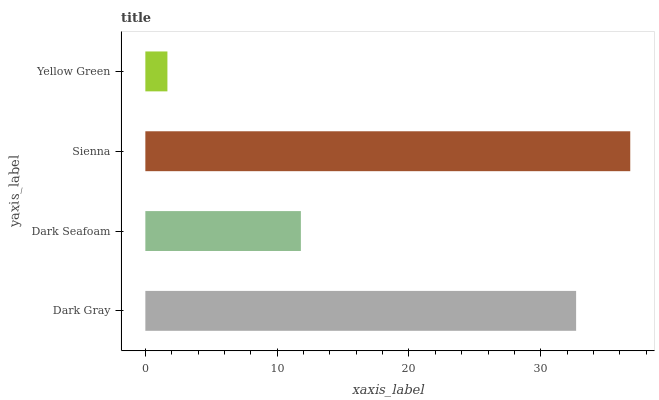Is Yellow Green the minimum?
Answer yes or no. Yes. Is Sienna the maximum?
Answer yes or no. Yes. Is Dark Seafoam the minimum?
Answer yes or no. No. Is Dark Seafoam the maximum?
Answer yes or no. No. Is Dark Gray greater than Dark Seafoam?
Answer yes or no. Yes. Is Dark Seafoam less than Dark Gray?
Answer yes or no. Yes. Is Dark Seafoam greater than Dark Gray?
Answer yes or no. No. Is Dark Gray less than Dark Seafoam?
Answer yes or no. No. Is Dark Gray the high median?
Answer yes or no. Yes. Is Dark Seafoam the low median?
Answer yes or no. Yes. Is Dark Seafoam the high median?
Answer yes or no. No. Is Dark Gray the low median?
Answer yes or no. No. 